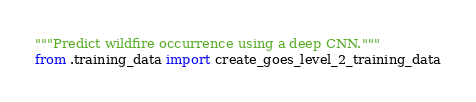Convert code to text. <code><loc_0><loc_0><loc_500><loc_500><_Python_>"""Predict wildfire occurrence using a deep CNN."""
from .training_data import create_goes_level_2_training_data
</code> 